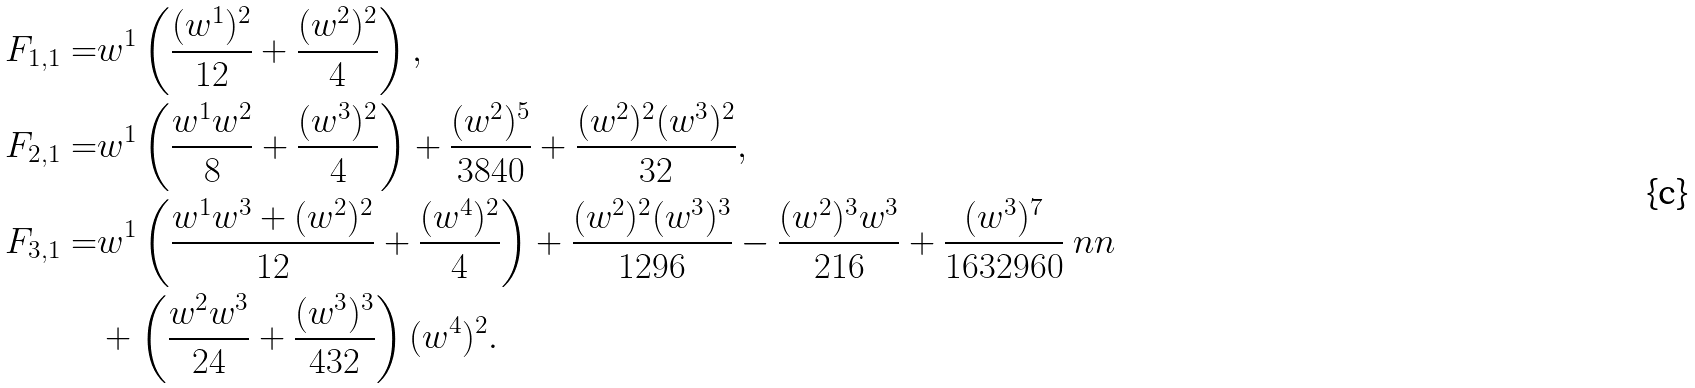Convert formula to latex. <formula><loc_0><loc_0><loc_500><loc_500>F _ { 1 , 1 } = & w ^ { 1 } \left ( \frac { ( w ^ { 1 } ) ^ { 2 } } { 1 2 } + \frac { ( w ^ { 2 } ) ^ { 2 } } { 4 } \right ) , \\ F _ { 2 , 1 } = & w ^ { 1 } \left ( \frac { w ^ { 1 } w ^ { 2 } } { 8 } + \frac { ( w ^ { 3 } ) ^ { 2 } } { 4 } \right ) + \frac { ( w ^ { 2 } ) ^ { 5 } } { 3 8 4 0 } + \frac { ( w ^ { 2 } ) ^ { 2 } ( w ^ { 3 } ) ^ { 2 } } { 3 2 } , \\ F _ { 3 , 1 } = & w ^ { 1 } \left ( \frac { w ^ { 1 } w ^ { 3 } + ( w ^ { 2 } ) ^ { 2 } } { 1 2 } + \frac { ( w ^ { 4 } ) ^ { 2 } } { 4 } \right ) + \frac { ( w ^ { 2 } ) ^ { 2 } ( w ^ { 3 } ) ^ { 3 } } { 1 2 9 6 } - \frac { ( w ^ { 2 } ) ^ { 3 } w ^ { 3 } } { 2 1 6 } + \frac { ( w ^ { 3 } ) ^ { 7 } } { 1 6 3 2 9 6 0 } \ n n \\ & + \left ( \frac { w ^ { 2 } w ^ { 3 } } { 2 4 } + \frac { ( w ^ { 3 } ) ^ { 3 } } { 4 3 2 } \right ) ( w ^ { 4 } ) ^ { 2 } .</formula> 